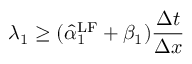<formula> <loc_0><loc_0><loc_500><loc_500>\lambda _ { 1 } \geq ( \hat { \alpha } _ { 1 } ^ { L F } + \beta _ { 1 } ) \frac { \Delta t } { \Delta x }</formula> 